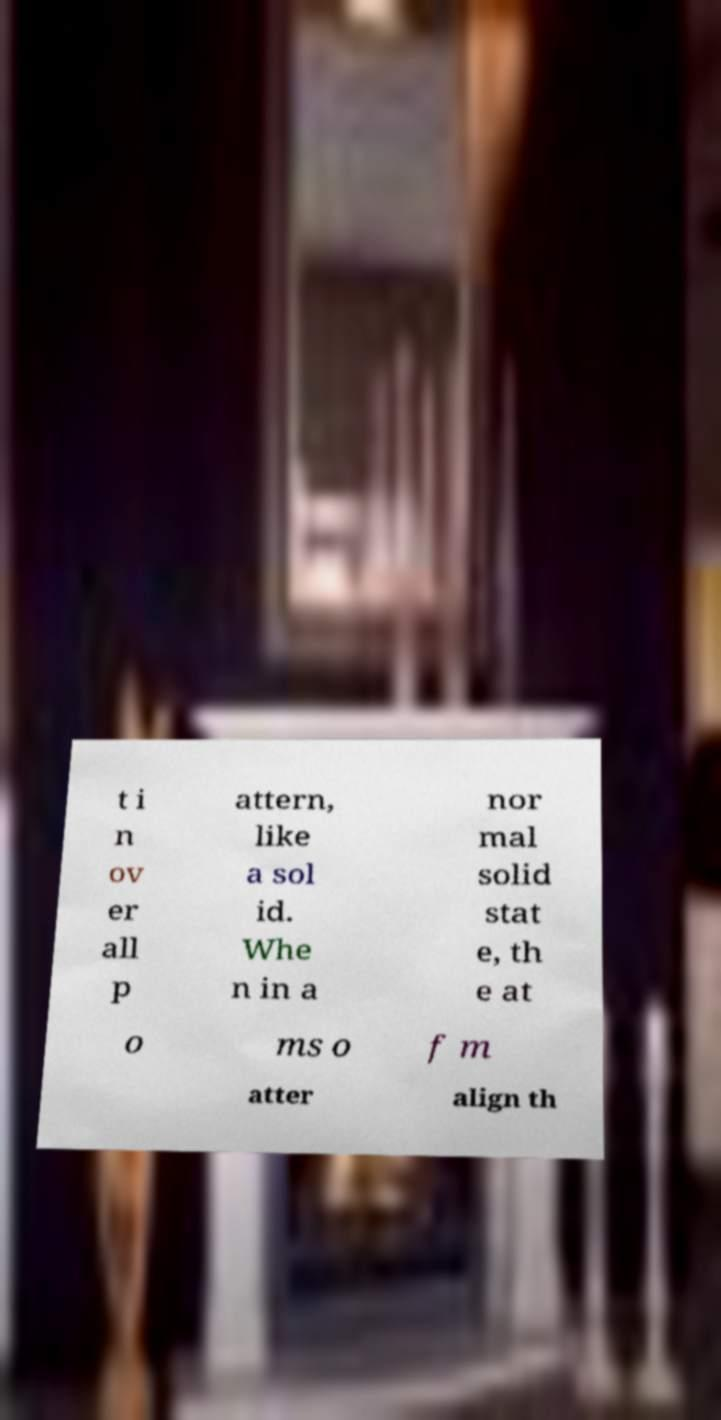Please read and relay the text visible in this image. What does it say? t i n ov er all p attern, like a sol id. Whe n in a nor mal solid stat e, th e at o ms o f m atter align th 